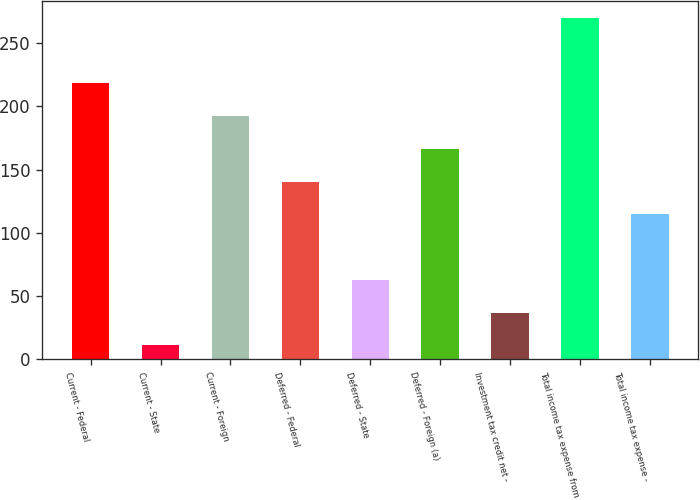Convert chart. <chart><loc_0><loc_0><loc_500><loc_500><bar_chart><fcel>Current - Federal<fcel>Current - State<fcel>Current - Foreign<fcel>Deferred - Federal<fcel>Deferred - State<fcel>Deferred - Foreign (a)<fcel>Investment tax credit net -<fcel>Total income tax expense from<fcel>Total income tax expense -<nl><fcel>218.2<fcel>11<fcel>192.3<fcel>140.5<fcel>62.8<fcel>166.4<fcel>36.9<fcel>270<fcel>114.6<nl></chart> 